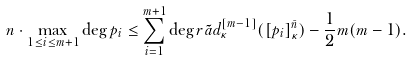<formula> <loc_0><loc_0><loc_500><loc_500>n \cdot \max _ { 1 \leq i \leq m + 1 } \deg p _ { i } & \leq \sum _ { i = 1 } ^ { m + 1 } \deg r \tilde { a } d _ { \kappa } ^ { [ m - 1 ] } ( [ p _ { i } ] _ { \kappa } ^ { \bar { n } } ) - \frac { 1 } { 2 } m ( m - 1 ) .</formula> 